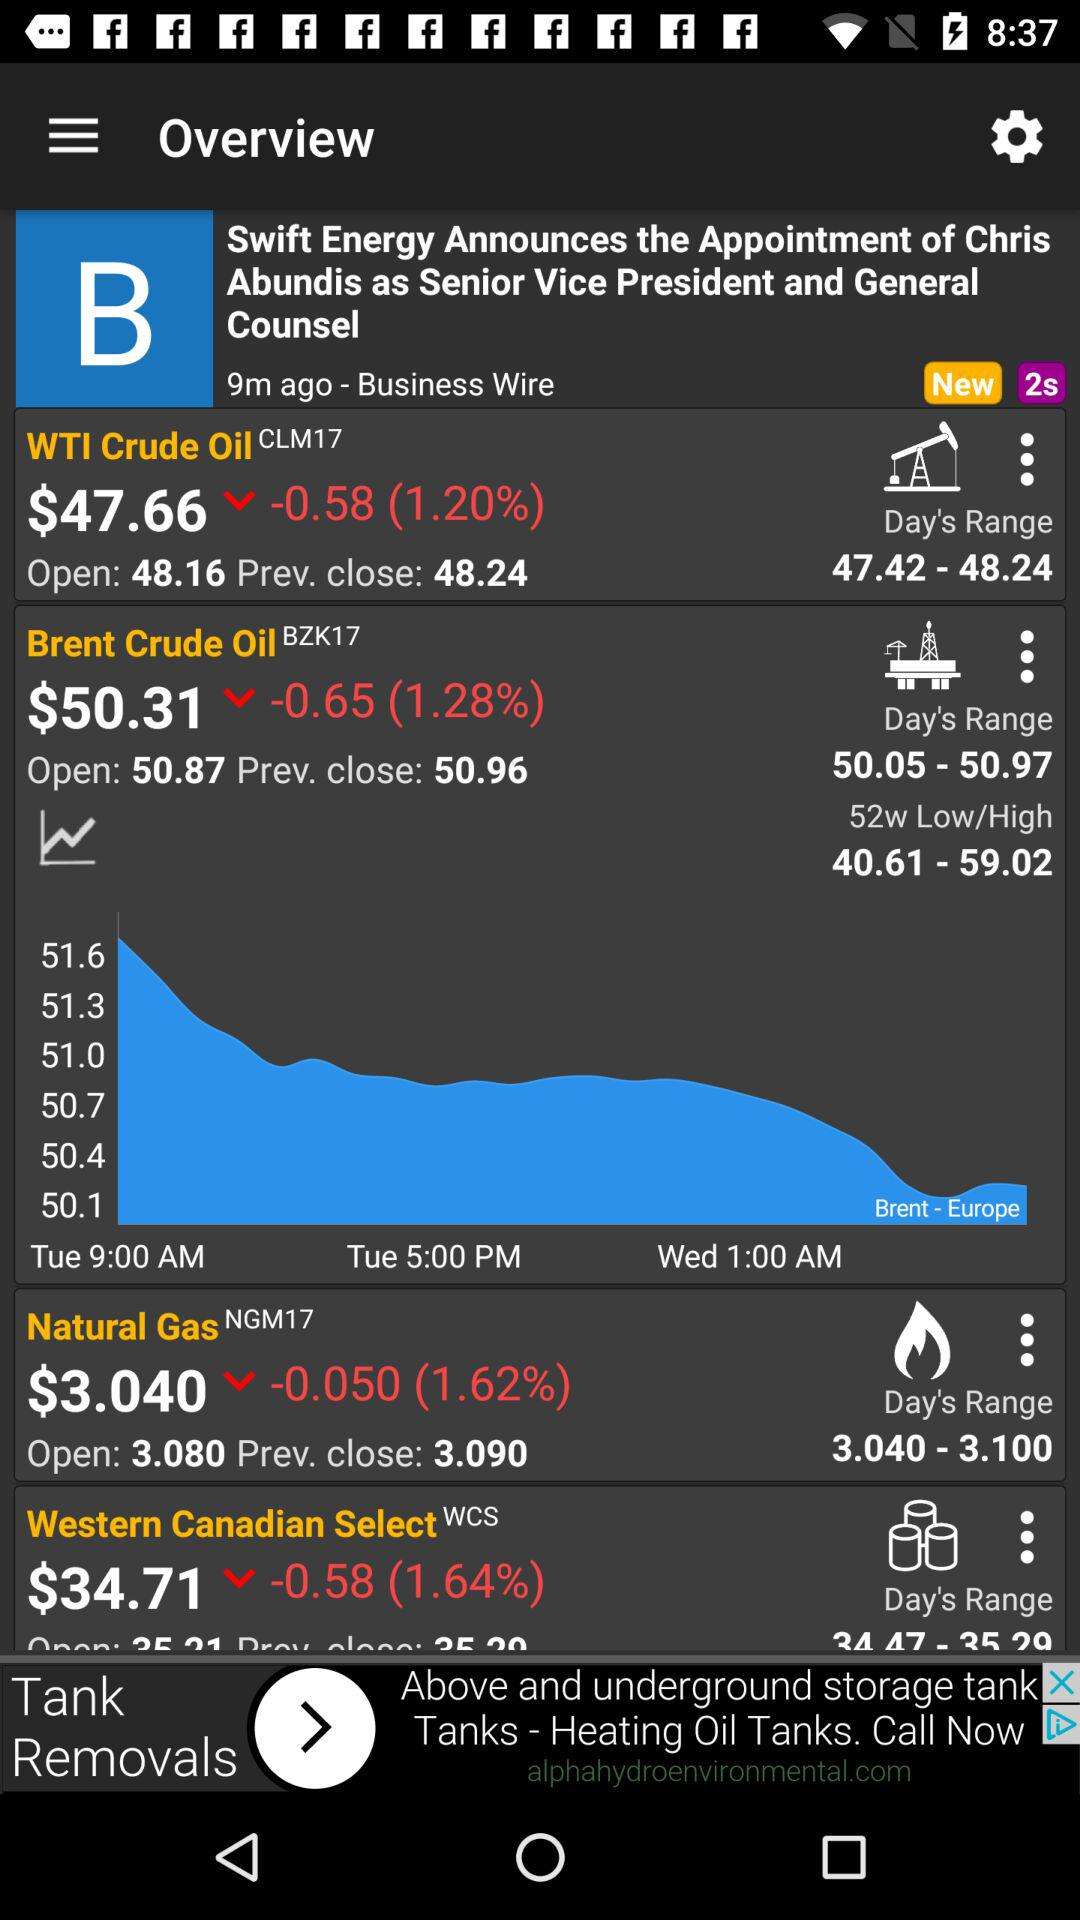What is the closing value of "WTI Crude Oil"? The closing value is 48.24. 